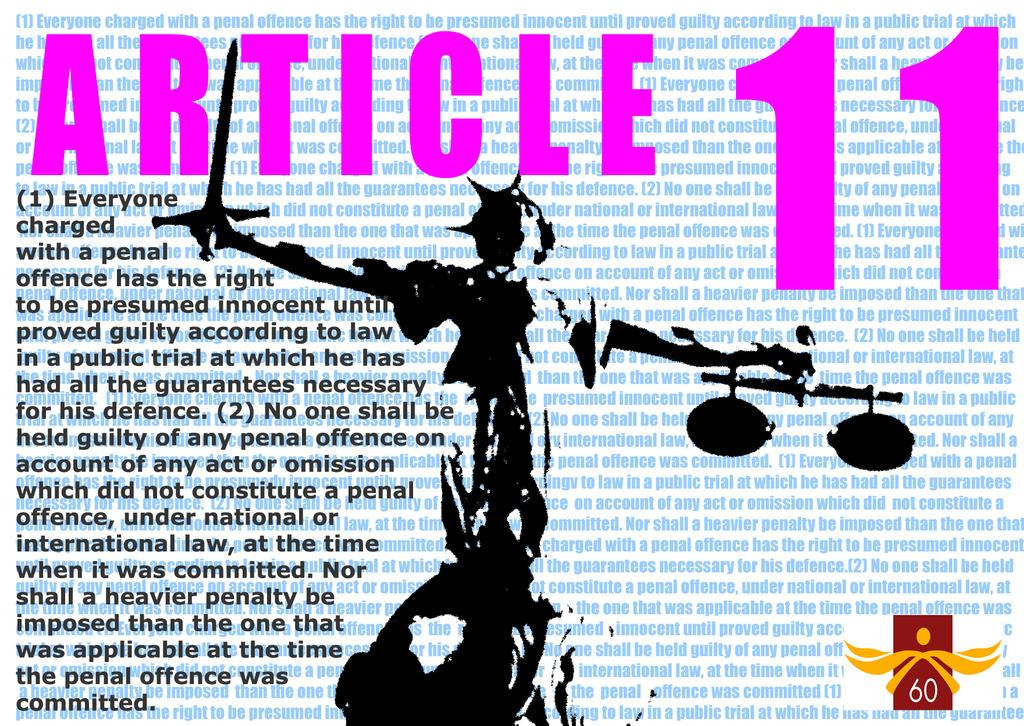<image>
Relay a brief, clear account of the picture shown. The statue of liberty is below the text Article 11. 